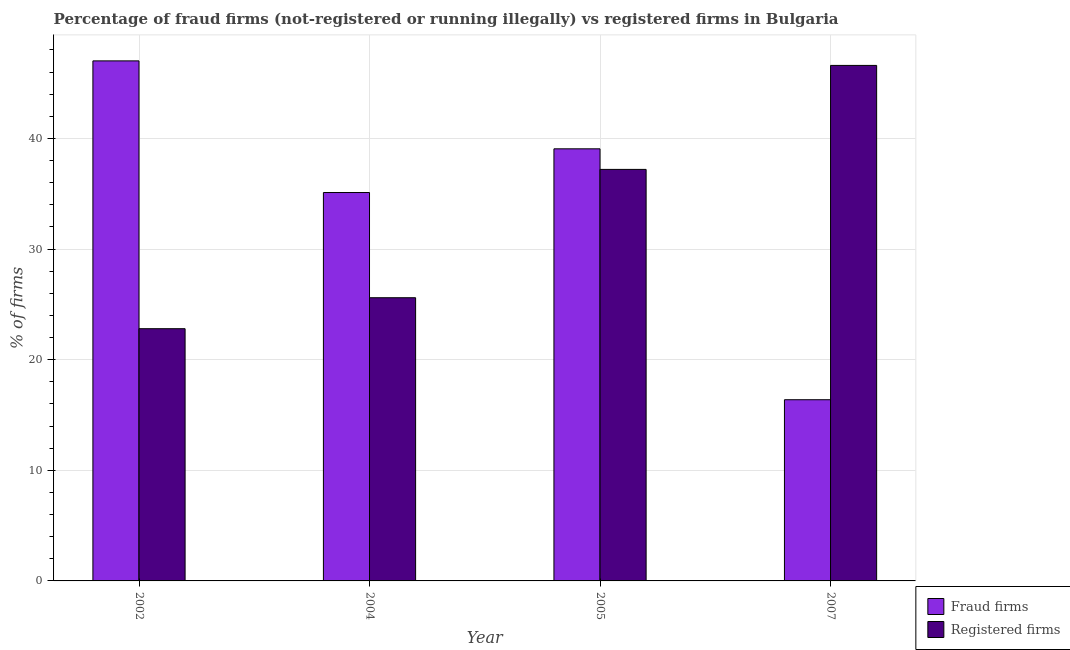How many different coloured bars are there?
Provide a succinct answer. 2. How many groups of bars are there?
Keep it short and to the point. 4. How many bars are there on the 2nd tick from the left?
Provide a short and direct response. 2. How many bars are there on the 1st tick from the right?
Provide a succinct answer. 2. What is the label of the 1st group of bars from the left?
Your answer should be very brief. 2002. What is the percentage of fraud firms in 2007?
Make the answer very short. 16.38. Across all years, what is the maximum percentage of registered firms?
Offer a terse response. 46.6. Across all years, what is the minimum percentage of registered firms?
Keep it short and to the point. 22.8. In which year was the percentage of registered firms maximum?
Provide a succinct answer. 2007. In which year was the percentage of fraud firms minimum?
Make the answer very short. 2007. What is the total percentage of registered firms in the graph?
Offer a very short reply. 132.2. What is the difference between the percentage of fraud firms in 2002 and that in 2004?
Your answer should be very brief. 11.9. What is the difference between the percentage of registered firms in 2005 and the percentage of fraud firms in 2004?
Your answer should be compact. 11.6. What is the average percentage of fraud firms per year?
Make the answer very short. 34.39. In the year 2007, what is the difference between the percentage of registered firms and percentage of fraud firms?
Your response must be concise. 0. What is the ratio of the percentage of fraud firms in 2002 to that in 2004?
Provide a short and direct response. 1.34. Is the percentage of registered firms in 2005 less than that in 2007?
Your answer should be compact. Yes. What is the difference between the highest and the second highest percentage of fraud firms?
Your response must be concise. 7.95. What is the difference between the highest and the lowest percentage of fraud firms?
Your response must be concise. 30.63. What does the 1st bar from the left in 2004 represents?
Keep it short and to the point. Fraud firms. What does the 1st bar from the right in 2007 represents?
Offer a very short reply. Registered firms. How many bars are there?
Give a very brief answer. 8. Are all the bars in the graph horizontal?
Ensure brevity in your answer.  No. How many years are there in the graph?
Your answer should be compact. 4. What is the difference between two consecutive major ticks on the Y-axis?
Your answer should be very brief. 10. Are the values on the major ticks of Y-axis written in scientific E-notation?
Your answer should be very brief. No. Does the graph contain grids?
Keep it short and to the point. Yes. How are the legend labels stacked?
Ensure brevity in your answer.  Vertical. What is the title of the graph?
Your response must be concise. Percentage of fraud firms (not-registered or running illegally) vs registered firms in Bulgaria. Does "Electricity" appear as one of the legend labels in the graph?
Give a very brief answer. No. What is the label or title of the X-axis?
Make the answer very short. Year. What is the label or title of the Y-axis?
Offer a very short reply. % of firms. What is the % of firms in Fraud firms in 2002?
Your answer should be compact. 47.01. What is the % of firms of Registered firms in 2002?
Offer a very short reply. 22.8. What is the % of firms in Fraud firms in 2004?
Your response must be concise. 35.11. What is the % of firms in Registered firms in 2004?
Provide a succinct answer. 25.6. What is the % of firms of Fraud firms in 2005?
Offer a very short reply. 39.06. What is the % of firms in Registered firms in 2005?
Your answer should be very brief. 37.2. What is the % of firms in Fraud firms in 2007?
Your response must be concise. 16.38. What is the % of firms in Registered firms in 2007?
Make the answer very short. 46.6. Across all years, what is the maximum % of firms in Fraud firms?
Offer a very short reply. 47.01. Across all years, what is the maximum % of firms in Registered firms?
Your response must be concise. 46.6. Across all years, what is the minimum % of firms in Fraud firms?
Provide a succinct answer. 16.38. Across all years, what is the minimum % of firms in Registered firms?
Ensure brevity in your answer.  22.8. What is the total % of firms in Fraud firms in the graph?
Offer a very short reply. 137.56. What is the total % of firms of Registered firms in the graph?
Your answer should be compact. 132.2. What is the difference between the % of firms in Fraud firms in 2002 and that in 2005?
Offer a very short reply. 7.95. What is the difference between the % of firms in Registered firms in 2002 and that in 2005?
Give a very brief answer. -14.4. What is the difference between the % of firms of Fraud firms in 2002 and that in 2007?
Offer a terse response. 30.63. What is the difference between the % of firms in Registered firms in 2002 and that in 2007?
Your answer should be compact. -23.8. What is the difference between the % of firms of Fraud firms in 2004 and that in 2005?
Your response must be concise. -3.95. What is the difference between the % of firms in Fraud firms in 2004 and that in 2007?
Give a very brief answer. 18.73. What is the difference between the % of firms in Fraud firms in 2005 and that in 2007?
Your answer should be compact. 22.68. What is the difference between the % of firms of Registered firms in 2005 and that in 2007?
Make the answer very short. -9.4. What is the difference between the % of firms in Fraud firms in 2002 and the % of firms in Registered firms in 2004?
Give a very brief answer. 21.41. What is the difference between the % of firms in Fraud firms in 2002 and the % of firms in Registered firms in 2005?
Give a very brief answer. 9.81. What is the difference between the % of firms of Fraud firms in 2002 and the % of firms of Registered firms in 2007?
Give a very brief answer. 0.41. What is the difference between the % of firms in Fraud firms in 2004 and the % of firms in Registered firms in 2005?
Your answer should be compact. -2.09. What is the difference between the % of firms in Fraud firms in 2004 and the % of firms in Registered firms in 2007?
Ensure brevity in your answer.  -11.49. What is the difference between the % of firms in Fraud firms in 2005 and the % of firms in Registered firms in 2007?
Provide a succinct answer. -7.54. What is the average % of firms in Fraud firms per year?
Keep it short and to the point. 34.39. What is the average % of firms of Registered firms per year?
Keep it short and to the point. 33.05. In the year 2002, what is the difference between the % of firms of Fraud firms and % of firms of Registered firms?
Your answer should be compact. 24.21. In the year 2004, what is the difference between the % of firms of Fraud firms and % of firms of Registered firms?
Your answer should be compact. 9.51. In the year 2005, what is the difference between the % of firms of Fraud firms and % of firms of Registered firms?
Your response must be concise. 1.86. In the year 2007, what is the difference between the % of firms of Fraud firms and % of firms of Registered firms?
Your answer should be very brief. -30.22. What is the ratio of the % of firms of Fraud firms in 2002 to that in 2004?
Give a very brief answer. 1.34. What is the ratio of the % of firms in Registered firms in 2002 to that in 2004?
Your response must be concise. 0.89. What is the ratio of the % of firms in Fraud firms in 2002 to that in 2005?
Ensure brevity in your answer.  1.2. What is the ratio of the % of firms of Registered firms in 2002 to that in 2005?
Your response must be concise. 0.61. What is the ratio of the % of firms in Fraud firms in 2002 to that in 2007?
Give a very brief answer. 2.87. What is the ratio of the % of firms of Registered firms in 2002 to that in 2007?
Your answer should be compact. 0.49. What is the ratio of the % of firms in Fraud firms in 2004 to that in 2005?
Provide a succinct answer. 0.9. What is the ratio of the % of firms of Registered firms in 2004 to that in 2005?
Ensure brevity in your answer.  0.69. What is the ratio of the % of firms in Fraud firms in 2004 to that in 2007?
Your answer should be compact. 2.14. What is the ratio of the % of firms of Registered firms in 2004 to that in 2007?
Keep it short and to the point. 0.55. What is the ratio of the % of firms in Fraud firms in 2005 to that in 2007?
Keep it short and to the point. 2.38. What is the ratio of the % of firms in Registered firms in 2005 to that in 2007?
Keep it short and to the point. 0.8. What is the difference between the highest and the second highest % of firms in Fraud firms?
Give a very brief answer. 7.95. What is the difference between the highest and the second highest % of firms of Registered firms?
Give a very brief answer. 9.4. What is the difference between the highest and the lowest % of firms of Fraud firms?
Offer a terse response. 30.63. What is the difference between the highest and the lowest % of firms in Registered firms?
Your response must be concise. 23.8. 